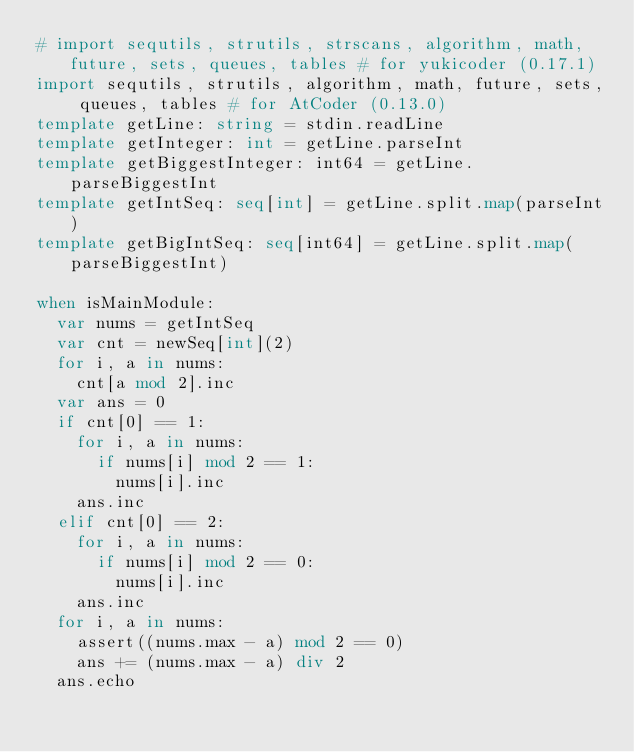Convert code to text. <code><loc_0><loc_0><loc_500><loc_500><_Nim_># import sequtils, strutils, strscans, algorithm, math, future, sets, queues, tables # for yukicoder (0.17.1)
import sequtils, strutils, algorithm, math, future, sets, queues, tables # for AtCoder (0.13.0)
template getLine: string = stdin.readLine
template getInteger: int = getLine.parseInt
template getBiggestInteger: int64 = getLine.parseBiggestInt
template getIntSeq: seq[int] = getLine.split.map(parseInt)
template getBigIntSeq: seq[int64] = getLine.split.map(parseBiggestInt)

when isMainModule:
  var nums = getIntSeq
  var cnt = newSeq[int](2)
  for i, a in nums:
    cnt[a mod 2].inc
  var ans = 0
  if cnt[0] == 1:
    for i, a in nums:
      if nums[i] mod 2 == 1:
        nums[i].inc
    ans.inc
  elif cnt[0] == 2:
    for i, a in nums:
      if nums[i] mod 2 == 0:
        nums[i].inc
    ans.inc
  for i, a in nums:
    assert((nums.max - a) mod 2 == 0)
    ans += (nums.max - a) div 2
  ans.echo
</code> 